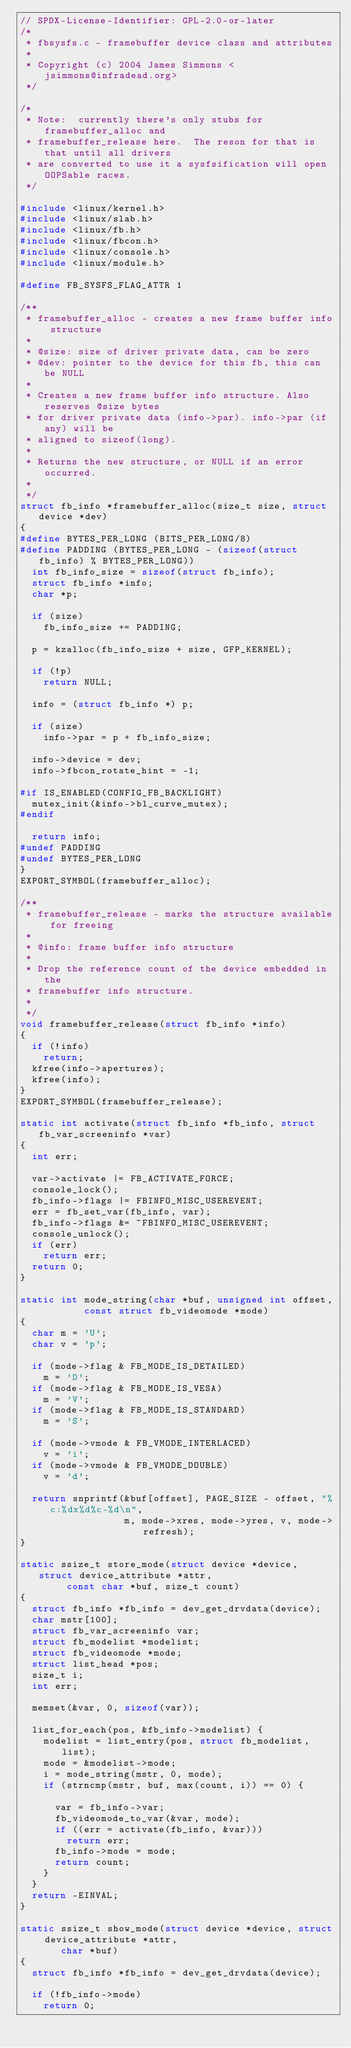<code> <loc_0><loc_0><loc_500><loc_500><_C_>// SPDX-License-Identifier: GPL-2.0-or-later
/*
 * fbsysfs.c - framebuffer device class and attributes
 *
 * Copyright (c) 2004 James Simmons <jsimmons@infradead.org>
 */

/*
 * Note:  currently there's only stubs for framebuffer_alloc and
 * framebuffer_release here.  The reson for that is that until all drivers
 * are converted to use it a sysfsification will open OOPSable races.
 */

#include <linux/kernel.h>
#include <linux/slab.h>
#include <linux/fb.h>
#include <linux/fbcon.h>
#include <linux/console.h>
#include <linux/module.h>

#define FB_SYSFS_FLAG_ATTR 1

/**
 * framebuffer_alloc - creates a new frame buffer info structure
 *
 * @size: size of driver private data, can be zero
 * @dev: pointer to the device for this fb, this can be NULL
 *
 * Creates a new frame buffer info structure. Also reserves @size bytes
 * for driver private data (info->par). info->par (if any) will be
 * aligned to sizeof(long).
 *
 * Returns the new structure, or NULL if an error occurred.
 *
 */
struct fb_info *framebuffer_alloc(size_t size, struct device *dev)
{
#define BYTES_PER_LONG (BITS_PER_LONG/8)
#define PADDING (BYTES_PER_LONG - (sizeof(struct fb_info) % BYTES_PER_LONG))
	int fb_info_size = sizeof(struct fb_info);
	struct fb_info *info;
	char *p;

	if (size)
		fb_info_size += PADDING;

	p = kzalloc(fb_info_size + size, GFP_KERNEL);

	if (!p)
		return NULL;

	info = (struct fb_info *) p;

	if (size)
		info->par = p + fb_info_size;

	info->device = dev;
	info->fbcon_rotate_hint = -1;

#if IS_ENABLED(CONFIG_FB_BACKLIGHT)
	mutex_init(&info->bl_curve_mutex);
#endif

	return info;
#undef PADDING
#undef BYTES_PER_LONG
}
EXPORT_SYMBOL(framebuffer_alloc);

/**
 * framebuffer_release - marks the structure available for freeing
 *
 * @info: frame buffer info structure
 *
 * Drop the reference count of the device embedded in the
 * framebuffer info structure.
 *
 */
void framebuffer_release(struct fb_info *info)
{
	if (!info)
		return;
	kfree(info->apertures);
	kfree(info);
}
EXPORT_SYMBOL(framebuffer_release);

static int activate(struct fb_info *fb_info, struct fb_var_screeninfo *var)
{
	int err;

	var->activate |= FB_ACTIVATE_FORCE;
	console_lock();
	fb_info->flags |= FBINFO_MISC_USEREVENT;
	err = fb_set_var(fb_info, var);
	fb_info->flags &= ~FBINFO_MISC_USEREVENT;
	console_unlock();
	if (err)
		return err;
	return 0;
}

static int mode_string(char *buf, unsigned int offset,
		       const struct fb_videomode *mode)
{
	char m = 'U';
	char v = 'p';

	if (mode->flag & FB_MODE_IS_DETAILED)
		m = 'D';
	if (mode->flag & FB_MODE_IS_VESA)
		m = 'V';
	if (mode->flag & FB_MODE_IS_STANDARD)
		m = 'S';

	if (mode->vmode & FB_VMODE_INTERLACED)
		v = 'i';
	if (mode->vmode & FB_VMODE_DOUBLE)
		v = 'd';

	return snprintf(&buf[offset], PAGE_SIZE - offset, "%c:%dx%d%c-%d\n",
	                m, mode->xres, mode->yres, v, mode->refresh);
}

static ssize_t store_mode(struct device *device, struct device_attribute *attr,
			  const char *buf, size_t count)
{
	struct fb_info *fb_info = dev_get_drvdata(device);
	char mstr[100];
	struct fb_var_screeninfo var;
	struct fb_modelist *modelist;
	struct fb_videomode *mode;
	struct list_head *pos;
	size_t i;
	int err;

	memset(&var, 0, sizeof(var));

	list_for_each(pos, &fb_info->modelist) {
		modelist = list_entry(pos, struct fb_modelist, list);
		mode = &modelist->mode;
		i = mode_string(mstr, 0, mode);
		if (strncmp(mstr, buf, max(count, i)) == 0) {

			var = fb_info->var;
			fb_videomode_to_var(&var, mode);
			if ((err = activate(fb_info, &var)))
				return err;
			fb_info->mode = mode;
			return count;
		}
	}
	return -EINVAL;
}

static ssize_t show_mode(struct device *device, struct device_attribute *attr,
			 char *buf)
{
	struct fb_info *fb_info = dev_get_drvdata(device);

	if (!fb_info->mode)
		return 0;
</code> 